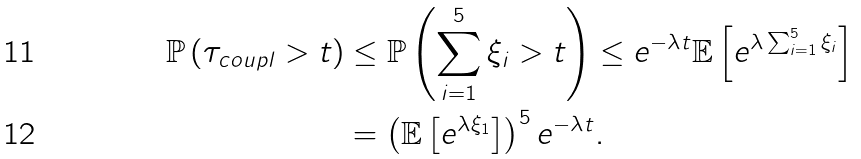Convert formula to latex. <formula><loc_0><loc_0><loc_500><loc_500>\mathbb { P } \left ( \tau _ { c o u p l } > t \right ) & \leq \mathbb { P } \left ( \sum _ { i = 1 } ^ { 5 } \xi _ { i } > t \right ) \leq e ^ { - \lambda t } \mathbb { E } \left [ e ^ { \lambda \sum _ { i = 1 } ^ { 5 } \xi _ { i } } \right ] \\ & = \left ( \mathbb { E } \left [ e ^ { \lambda \xi _ { 1 } } \right ] \right ) ^ { 5 } e ^ { - \lambda t } .</formula> 